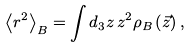<formula> <loc_0><loc_0><loc_500><loc_500>\left \langle r ^ { 2 } \right \rangle _ { B } = \int d _ { 3 } z \, z ^ { 2 } \rho _ { B } \left ( \vec { z } \right ) ,</formula> 